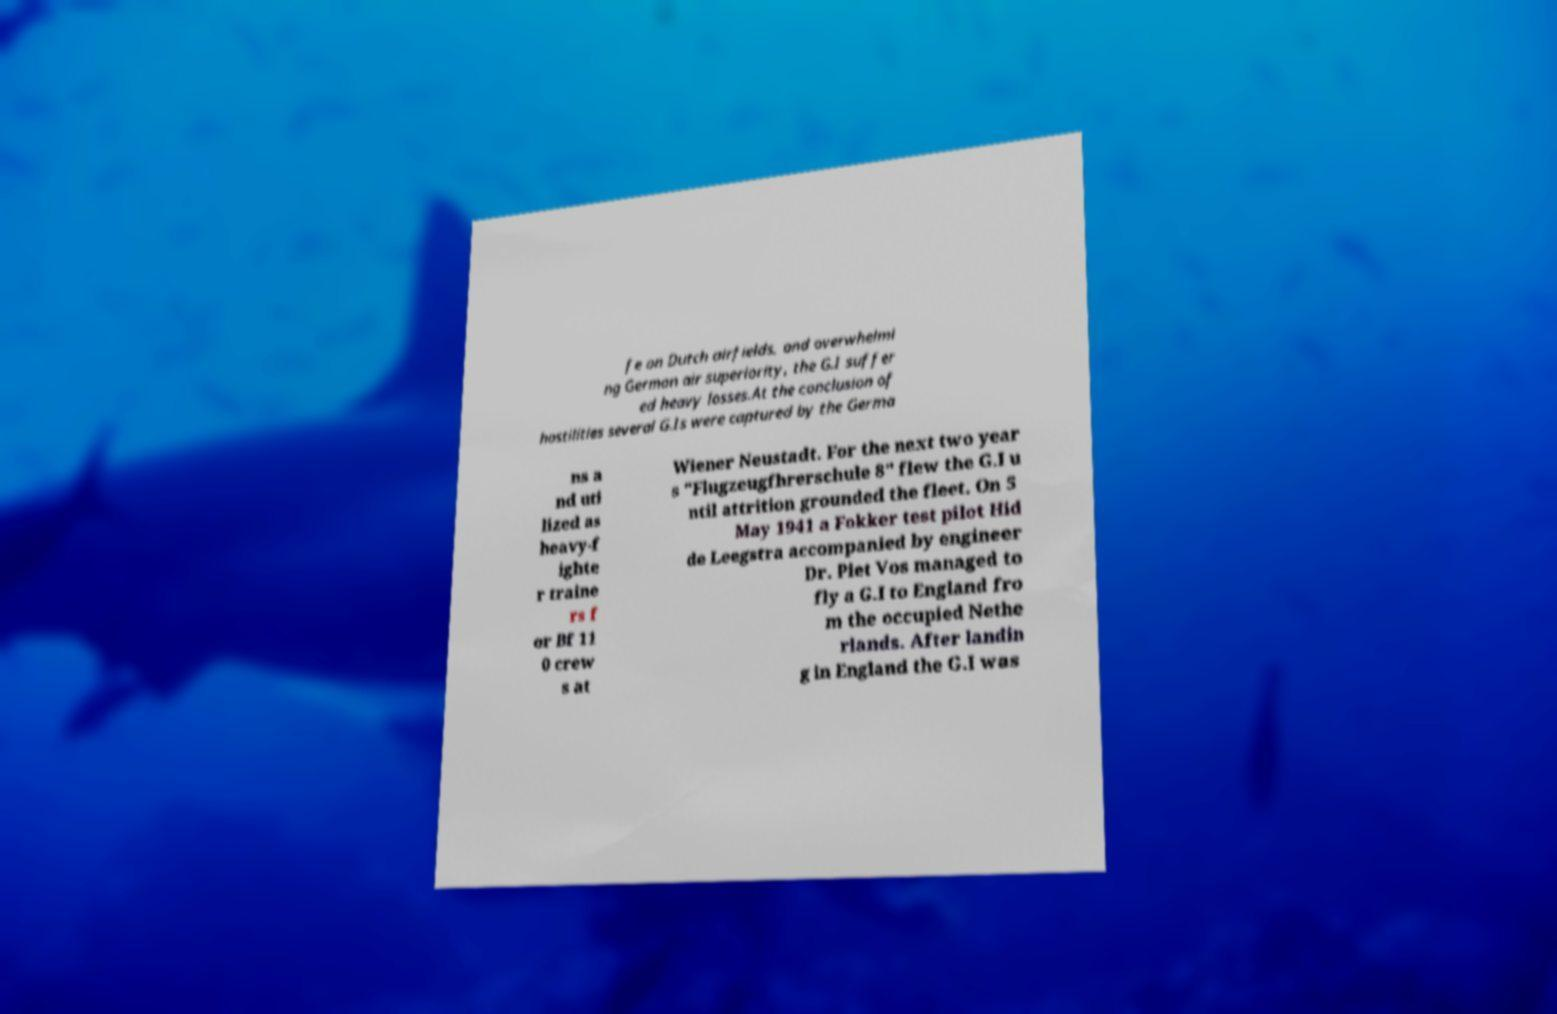Please identify and transcribe the text found in this image. fe on Dutch airfields, and overwhelmi ng German air superiority, the G.I suffer ed heavy losses.At the conclusion of hostilities several G.Is were captured by the Germa ns a nd uti lized as heavy-f ighte r traine rs f or Bf 11 0 crew s at Wiener Neustadt. For the next two year s "Flugzeugfhrerschule 8" flew the G.I u ntil attrition grounded the fleet. On 5 May 1941 a Fokker test pilot Hid de Leegstra accompanied by engineer Dr. Piet Vos managed to fly a G.I to England fro m the occupied Nethe rlands. After landin g in England the G.I was 